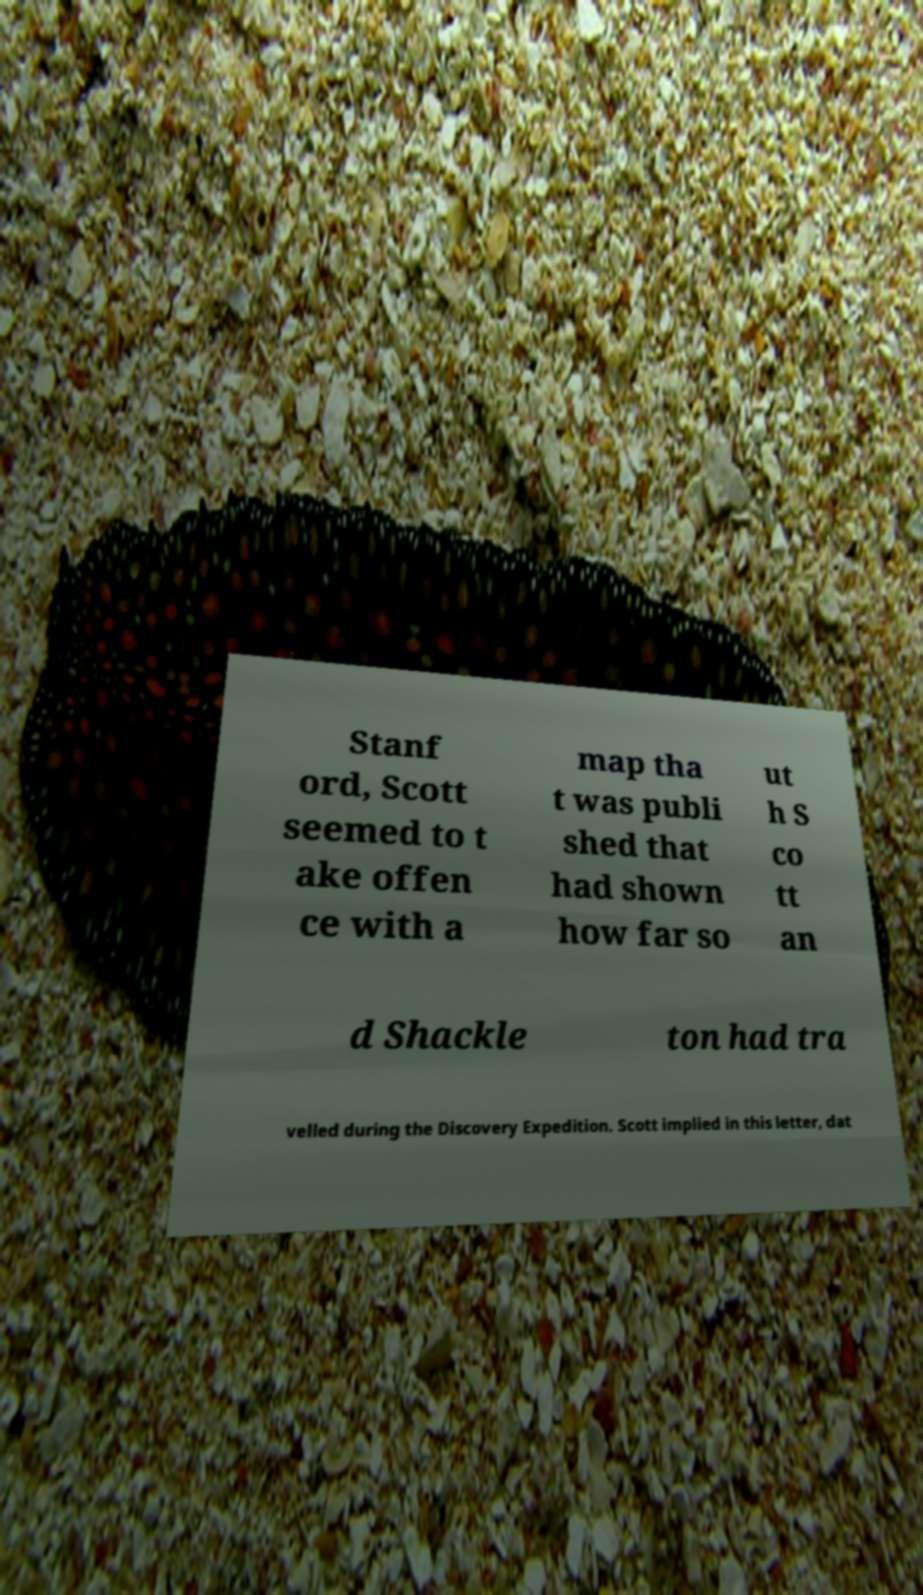Could you assist in decoding the text presented in this image and type it out clearly? Stanf ord, Scott seemed to t ake offen ce with a map tha t was publi shed that had shown how far so ut h S co tt an d Shackle ton had tra velled during the Discovery Expedition. Scott implied in this letter, dat 